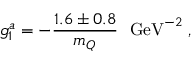<formula> <loc_0><loc_0><loc_500><loc_500>g _ { 1 } ^ { a } = - { \frac { 1 . 6 \pm 0 . 8 } { m _ { Q } } } G e V ^ { - 2 } \, ,</formula> 